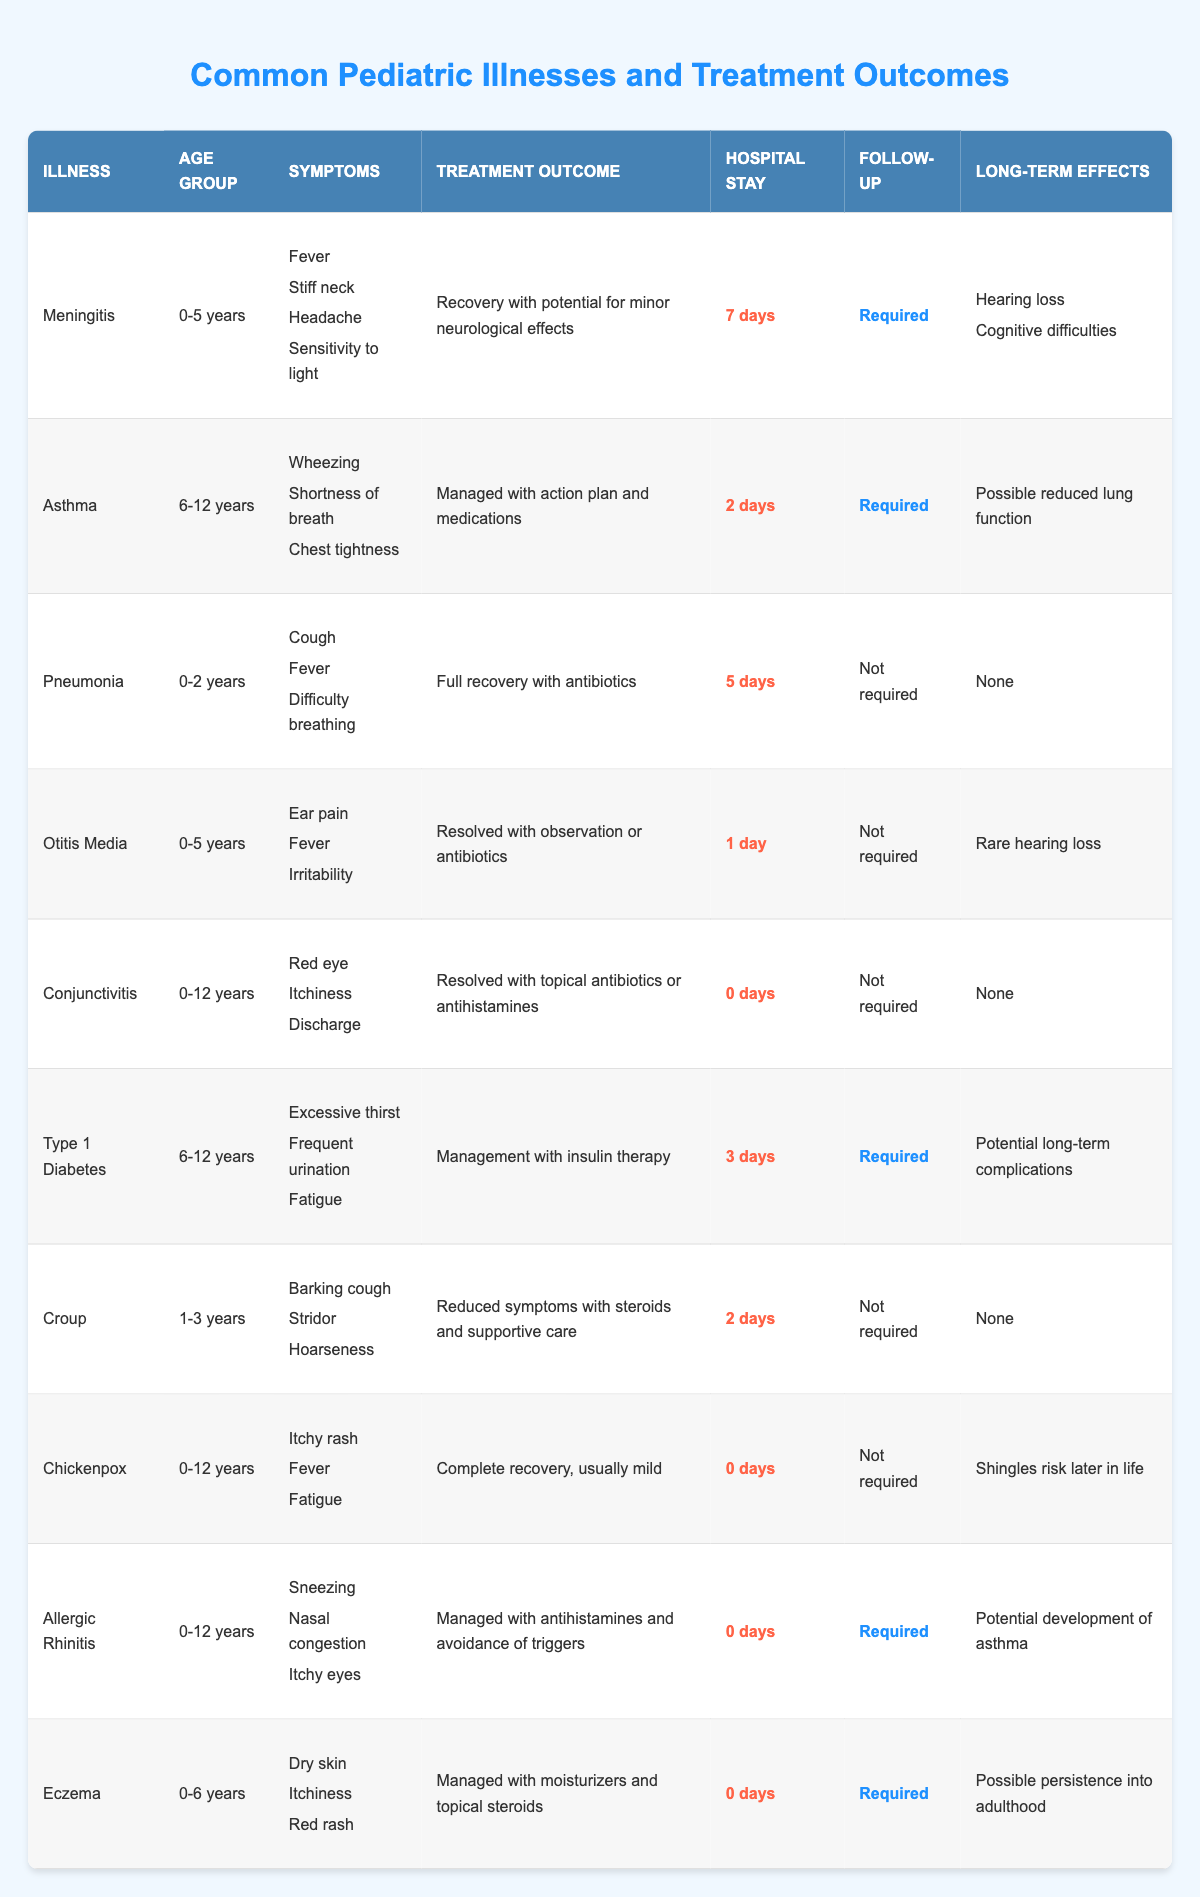What is the average length of hospital stay for the illnesses listed? The hospital stay days for each illness are: 7, 2, 5, 1, 0, 3, 2, 0, 0, 0. Calculating the sum: 7 + 2 + 5 + 1 + 0 + 3 + 2 + 0 + 0 + 0 = 20. There are 10 illnesses, so the average is 20 / 10 = 2.
Answer: 2 days Which illness has the longest hospital stay? By reviewing the hospital stay days: 7 for Meningitis, 2 for Asthma, 5 for Pneumonia, 1 for Otitis Media, 0 for Conjunctivitis, 3 for Type 1 Diabetes, 2 for Croup, and 0 for Chickenpox, Allergic Rhinitis, and Eczema. The illness with the longest stay is Meningitis with 7 days.
Answer: Meningitis Is follow-up care needed for all the illnesses? After checking the follow-up column, it shows that Meningitis, Asthma, Type 1 Diabetes, Allergic Rhinitis, and Eczema require follow-ups, while Pneumonia, Otitis Media, Conjunctivitis, Croup, and Chickenpox do not. Therefore, not all illnesses require follow-up care.
Answer: No How many illnesses result in potential long-term effects? Looking through the long-term effects column, Meningitis, Asthma, Type 1 Diabetes, Otitis Media, Chickenpox, and Eczema all mention potential long-term effects. Out of 10 illnesses, 6 have long-term effects listed.
Answer: 6 What are the common symptoms for illnesses affecting children aged 0-5 years? The illnesses affecting this age group are Meningitis, Otitis Media, Chickenpox, and Eczema. Their symptoms are as follows: Meningitis has fever, stiff neck, headache, sensitivity to light; Otitis Media has ear pain, fever, irritability; Chickenpox has itchy rash, fever, fatigue; Eczema has dry skin, itchiness, red rash. Common symptoms include fever and irritability from these illnesses.
Answer: Fever, irritability Which illness has the lowest hospital stay but still requires follow-up? The illnesses with 0 days of hospital stay are Conjunctivitis, Chickenpox, Allergic Rhinitis, and Eczema. Out of these, only Allergic Rhinitis and Eczema require follow-up care; therefore, Eczema has the lowest hospital stay at 0 days and requires a follow-up.
Answer: Eczema What are the long-term effects of Asthma? The long-term effects listed for Asthma indicate that there is a potential for reduced lung function. This is the only identified long-term effect for this illness according to the table.
Answer: Possible reduced lung function Are symptoms consistent across all illnesses? A review of the symptoms shows significant variation between illnesses. For example, Meningitis has severe symptoms like stiff neck and headache, while Conjunctivitis has mild symptoms like red eye and itchiness. Therefore, symptoms are not consistent across all illnesses.
Answer: No Which two illnesses require follow-up care and have significant long-term effects? The two illnesses that require follow-up care and have listed long-term effects are Meningitis (which can result in hearing loss and cognitive difficulties) and Type 1 Diabetes (which has potential long-term complications).
Answer: Meningitis and Type 1 Diabetes What percentage of illnesses require follow-up care? There are 10 illnesses in total, and 5 of them require follow-up care (Meningitis, Asthma, Type 1 Diabetes, Allergic Rhinitis, and Eczema). Therefore, the percentage is (5 / 10) * 100 = 50%.
Answer: 50% How many illnesses have no long-term effects associated with them? Upon reviewing the long-term effects for each illness, Pneumonia, Conjunctivitis, Croup, and Chickenpox show no long-term effects mentioned. Thus, there are 4 illnesses with no long-term effects.
Answer: 4 